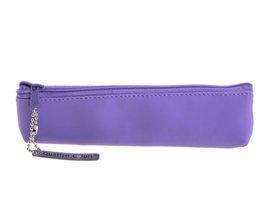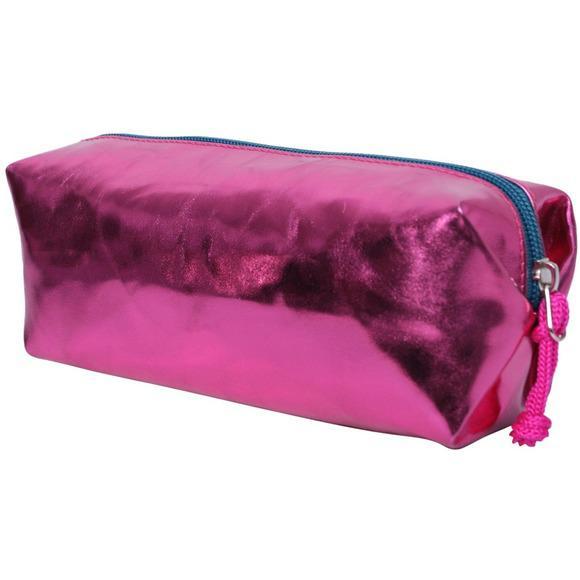The first image is the image on the left, the second image is the image on the right. Considering the images on both sides, is "The pencil case in one of the images in purple and the other is pink." valid? Answer yes or no. Yes. The first image is the image on the left, the second image is the image on the right. Given the left and right images, does the statement "There is one purple pencil case and one hot pink pencil case." hold true? Answer yes or no. Yes. 